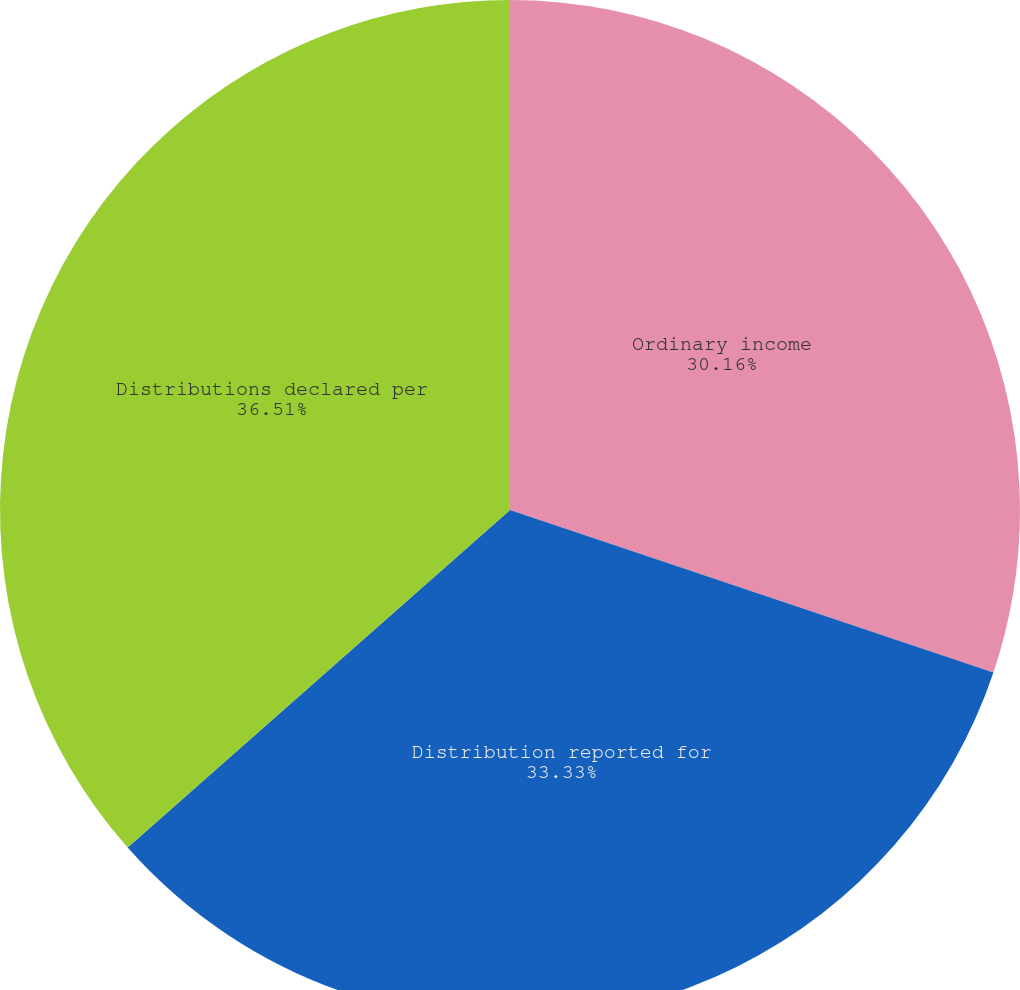Convert chart to OTSL. <chart><loc_0><loc_0><loc_500><loc_500><pie_chart><fcel>Ordinary income<fcel>Distribution reported for<fcel>Distributions declared per<nl><fcel>30.16%<fcel>33.33%<fcel>36.51%<nl></chart> 